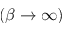Convert formula to latex. <formula><loc_0><loc_0><loc_500><loc_500>( \beta \to \infty )</formula> 